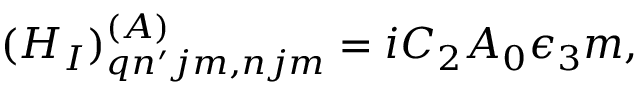<formula> <loc_0><loc_0><loc_500><loc_500>( H _ { I } ) _ { q n ^ { \prime } j m , n j m } ^ { ( A ) } = i C _ { 2 } A _ { 0 } \epsilon _ { 3 } m ,</formula> 